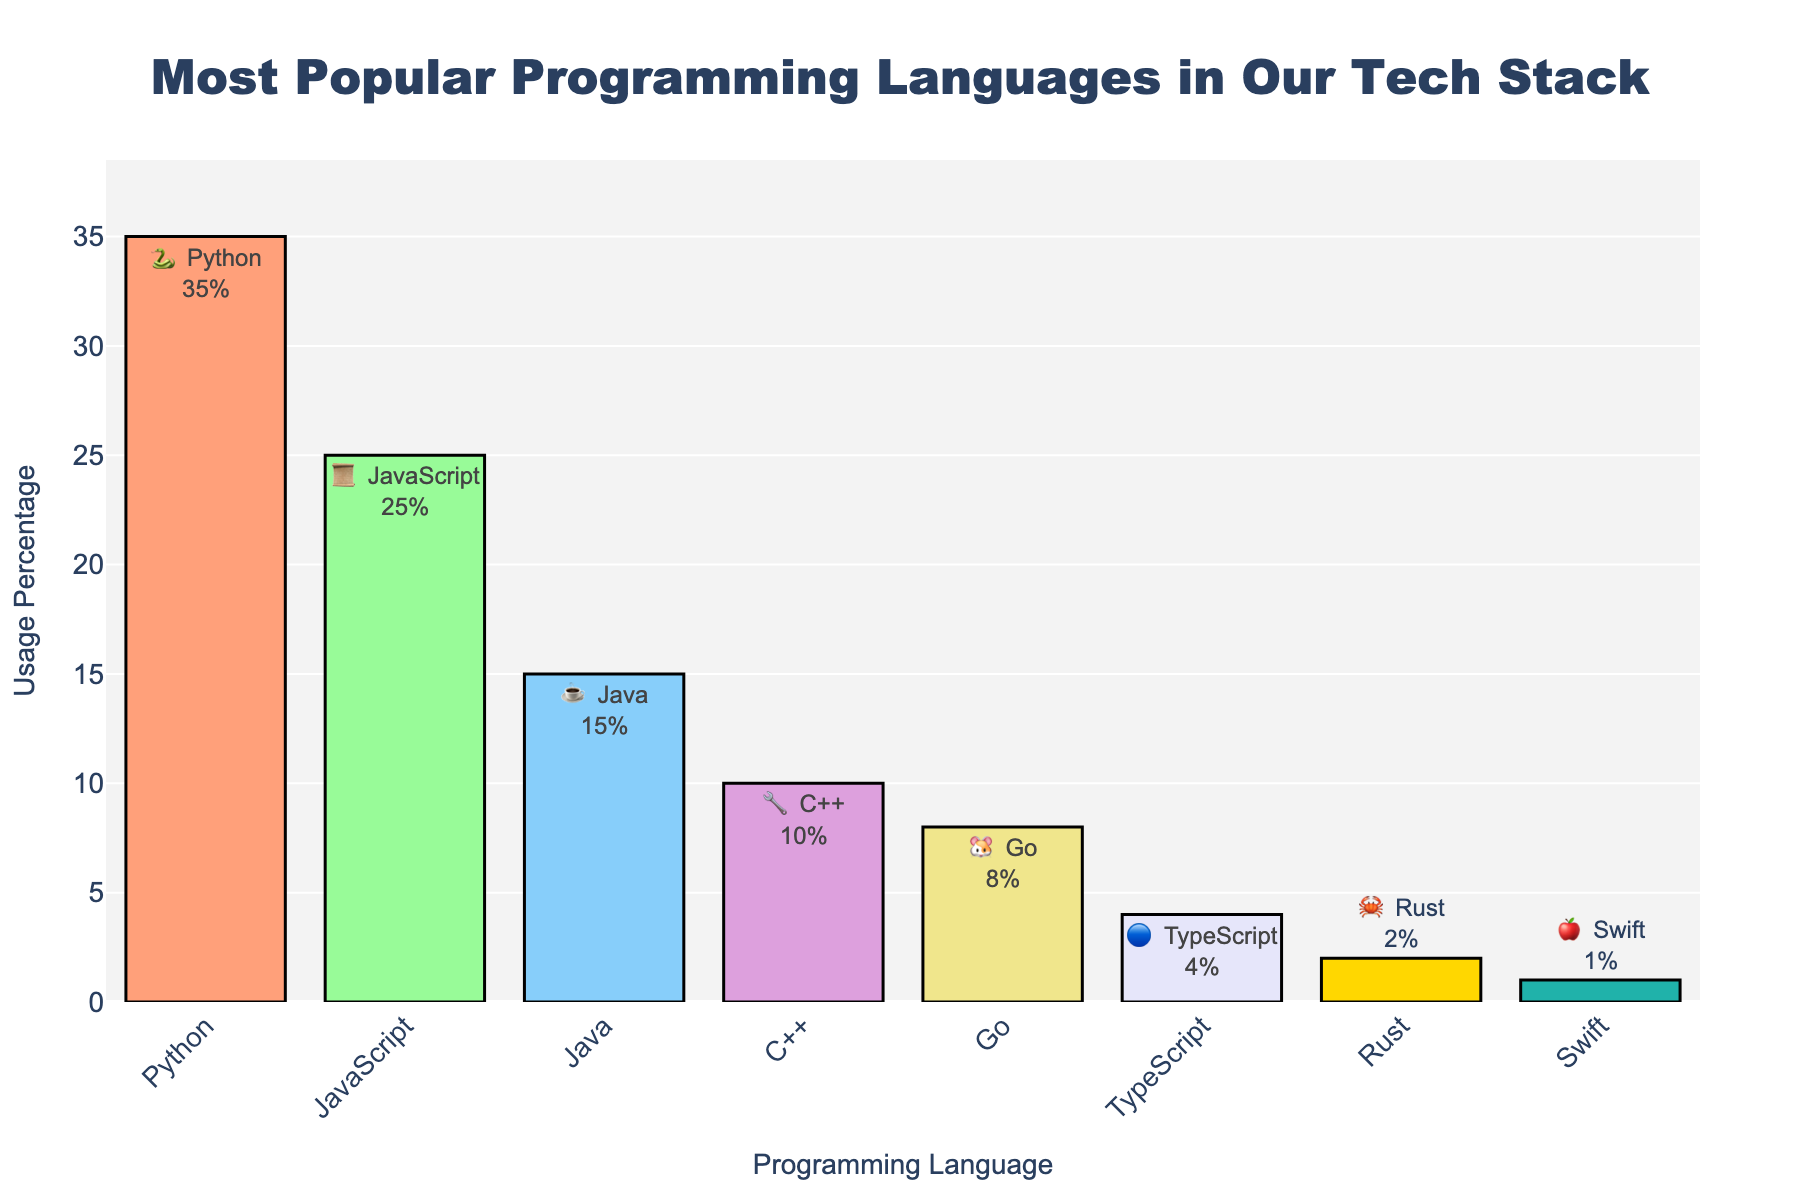What is the title of the chart? The title is prominently displayed at the top of the chart. It reads "Most Popular Programming Languages in Our Tech Stack".
Answer: Most Popular Programming Languages in Our Tech Stack What is the percentage usage of Python? The percentage usage for Python is labeled directly next to the Python emoji and is provided as 35%.
Answer: 35% Which programming language has the least usage percentage? By comparing all the usage percentages, Swift has the least with 1% next to its emoji.
Answer: Swift What is the difference in usage percentage between Python and JavaScript? Subtract JavaScript's 25% usage from Python's 35% usage to find the difference (35 - 25 = 10).
Answer: 10% What is the combined usage percentage of Go, TypeScript, and Rust? Add the usage percentages for Go (8%), TypeScript (4%), and Rust (2%). (8 + 4 + 2 = 14)
Answer: 14% Which language has a higher usage percentage, Java or C++? Java has a usage percentage of 15%, while C++ has 10%. Therefore, Java's usage is higher.
Answer: Java How many programming languages have a usage percentage greater than 10%? Python (35%), JavaScript (25%), and Java (15%) each have a usage greater than 10%. There are three such languages.
Answer: 3 Rank the languages by usage percentage from highest to lowest. By examining the usage percentages: Python (35%), JavaScript (25%), Java (15%), C++ (10%), Go (8%), TypeScript (4%), Rust (2%), Swift (1%).
Answer: Python, JavaScript, Java, C++, Go, TypeScript, Rust, Swift What emoji represents the usage of Go in the chart? The emoji used for Go is a hamster emoji 🐹, which is located next to the label for Go.
Answer: 🐹 Between TypeScript and Rust, which language has a lower usage percentage? Rust has a usage percentage of 2%, which is lower compared to TypeScript's 4%.
Answer: Rust 